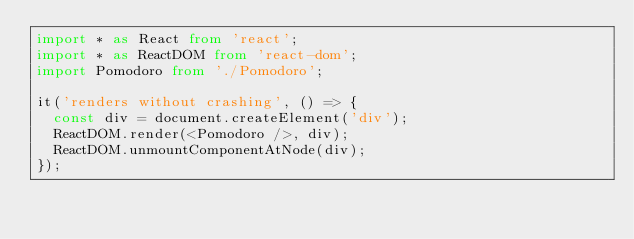<code> <loc_0><loc_0><loc_500><loc_500><_TypeScript_>import * as React from 'react';
import * as ReactDOM from 'react-dom';
import Pomodoro from './Pomodoro';

it('renders without crashing', () => {
  const div = document.createElement('div');
  ReactDOM.render(<Pomodoro />, div);
  ReactDOM.unmountComponentAtNode(div);
});
</code> 